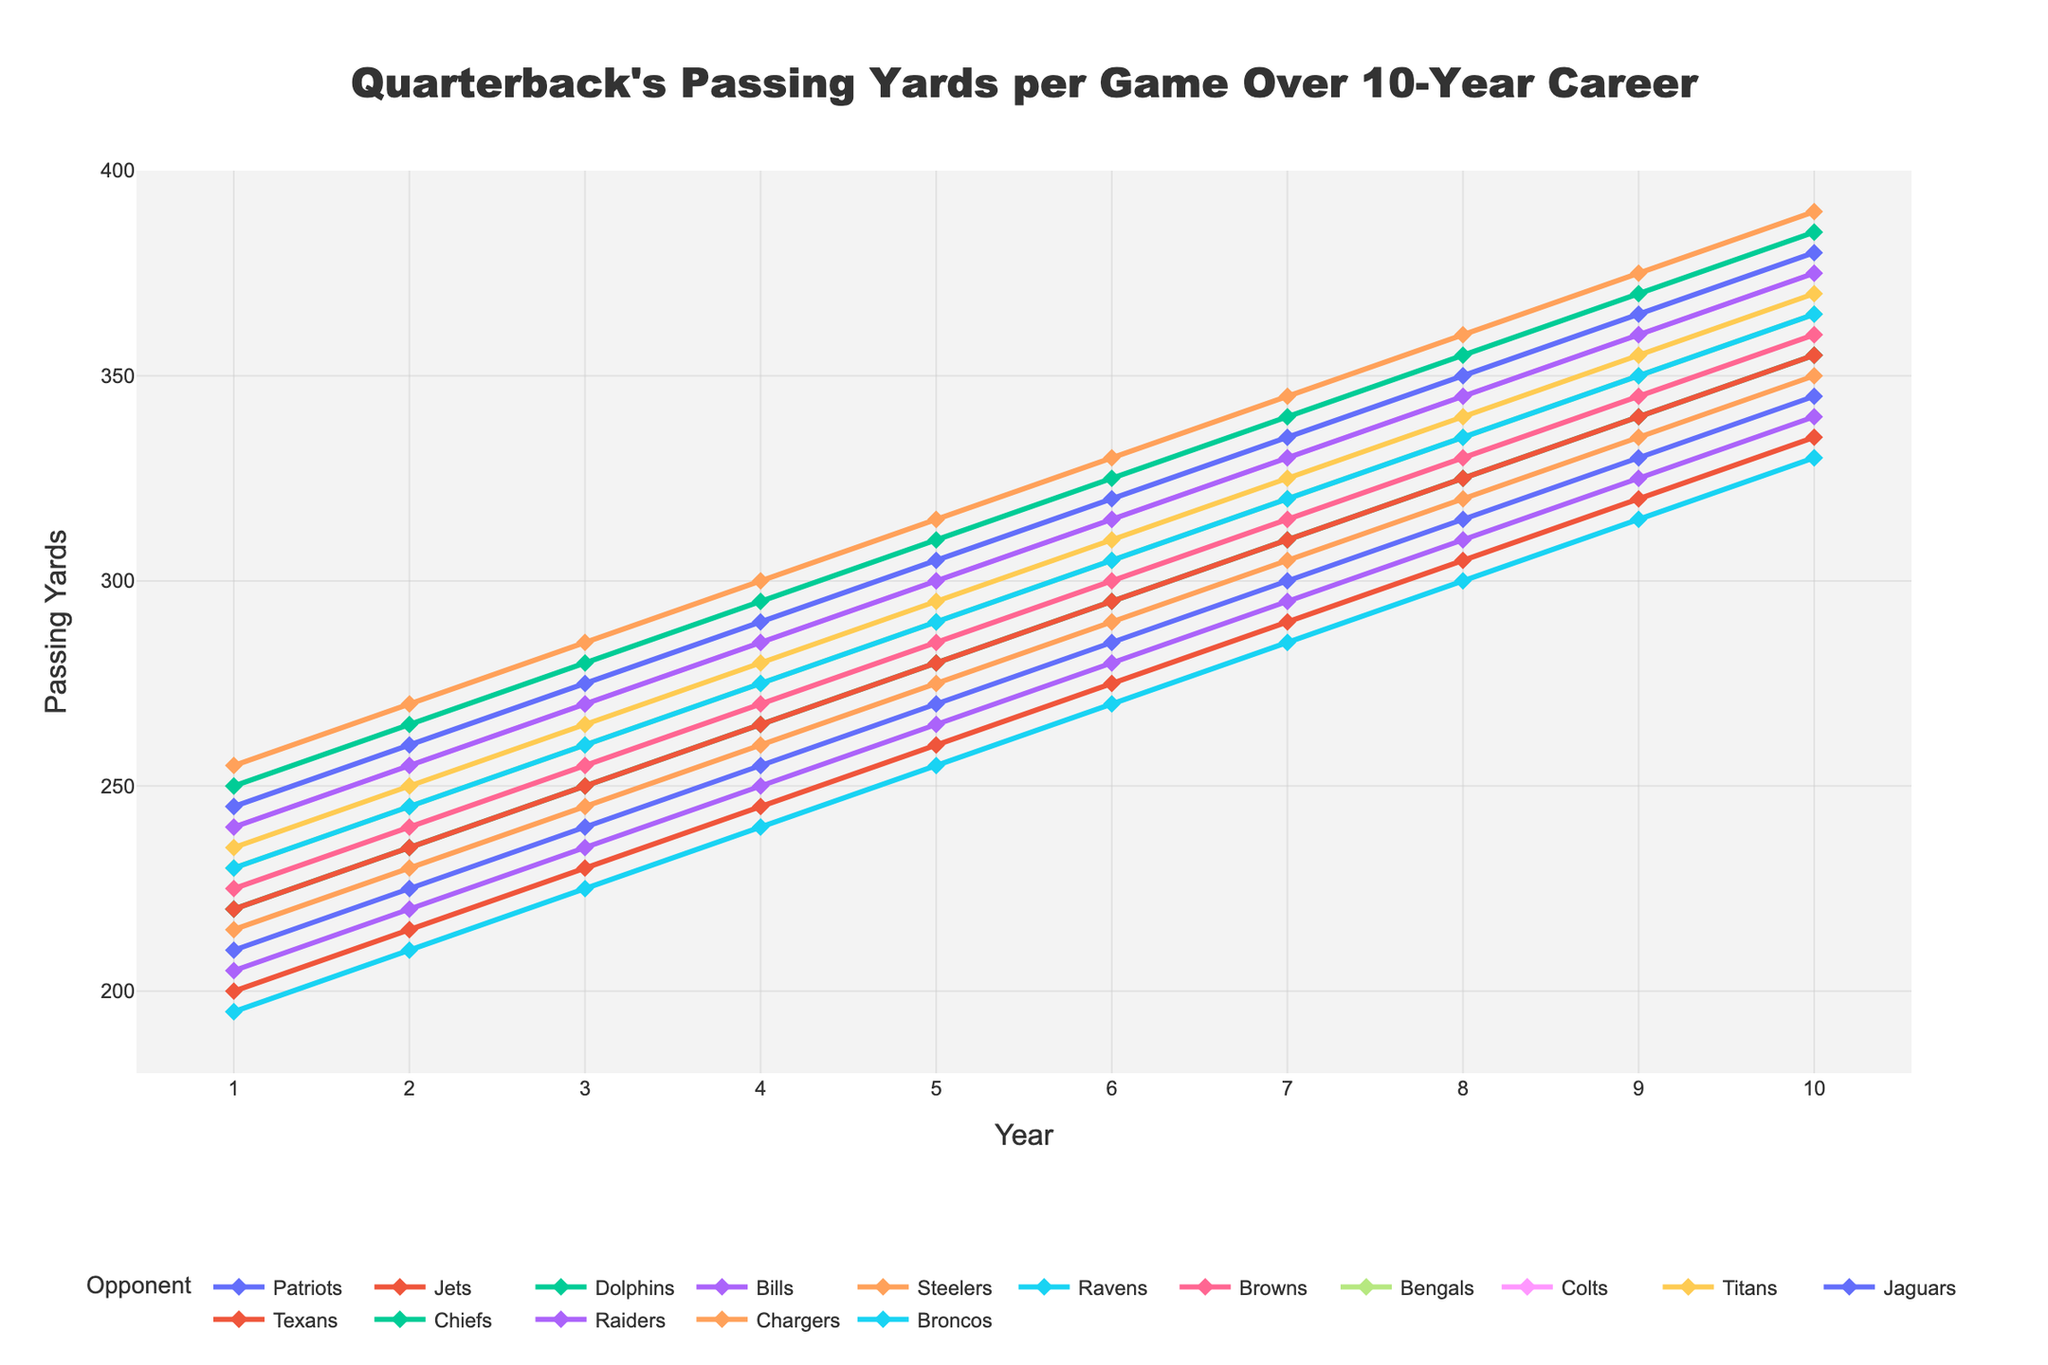Which opponent had the highest passing yards in Year 10? To find the opponent with the highest passing yards in Year 10, locate the highest point on the right side of the chart and identify the corresponding opponent.
Answer: Chargers How did the passing yards against the Patriots change from Year 1 to Year 10? To determine the change, observe the trend line for the Patriots from Year 1 (210 yards) to Year 10 (345 yards). Subtract the Year 1 value from the Year 10 value: 345 - 210 = 135 yards increase.
Answer: Increased by 135 yards Which opponent shows the most consistent year-to-year increase in passing yards? Look for the opponent whose line has the most regular and smooth upward slope without any noticeable irregularities. The Jets' line appears to have consistent increments each year.
Answer: Jets What's the combined total passing yards against the Ravens over the 10 years? Add up the values for each year against the Ravens: 195 + 210 + 225 + 240 + 255 + 270 + 285 + 300 + 315 + 330 = 2625 yards.
Answer: 2625 yards Which two opponents had the closest passing yards in Year 5? Compare the values for Year 5 across all opponents and identify the two with the closest values. For Year 5, the Texans (280 yards) and Dolphins (280 yards) had equal values.
Answer: Texans and Dolphins Between Year 1 and Year 10, which opponent saw the greatest percentage increase in passing yards? Calculate the percentage increase for each opponent using the formula [(Year 10 - Year 1) / Year 1] * 100. Chargers had the highest percentage increase: [(390 - 255) / 255] * 100 ≈ 52.94%.
Answer: Chargers In which year did the Browns first surpass 300 passing yards? Observe the trend for the Browns and identify the first year where their passing yards exceed 300. This occurs in Year 6 with 300 yards.
Answer: Year 6 Which opponent has the steepest slope in their trend line from Year 4 to Year 5? Identify the opponent whose line segment between Year 4 and Year 5 has the steepest slope. The Chiefs' trend line appears the steepest from Year 4 (290 yards) to Year 5 (305 yards), a 15-yard year-to-year increase.
Answer: Chiefs Which two opponents had the largest discrepancy in passing yards in Year 7? Compare the values for Year 7 across all opponents and identify the two with the largest difference. The Chiefs (340 yards) and Ravens (285 yards) had the greatest difference, which is 55 yards.
Answer: Chiefs and Ravens 